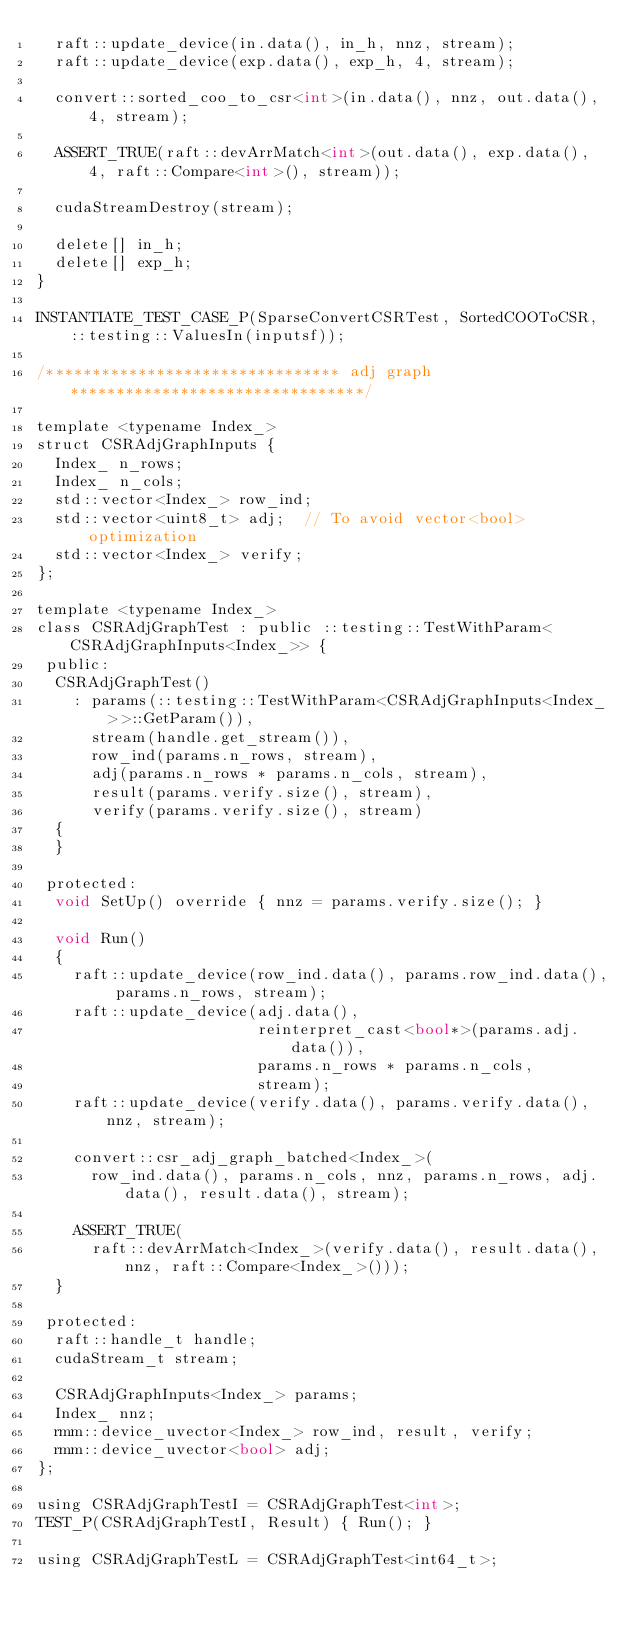<code> <loc_0><loc_0><loc_500><loc_500><_Cuda_>  raft::update_device(in.data(), in_h, nnz, stream);
  raft::update_device(exp.data(), exp_h, 4, stream);

  convert::sorted_coo_to_csr<int>(in.data(), nnz, out.data(), 4, stream);

  ASSERT_TRUE(raft::devArrMatch<int>(out.data(), exp.data(), 4, raft::Compare<int>(), stream));

  cudaStreamDestroy(stream);

  delete[] in_h;
  delete[] exp_h;
}

INSTANTIATE_TEST_CASE_P(SparseConvertCSRTest, SortedCOOToCSR, ::testing::ValuesIn(inputsf));

/******************************** adj graph ********************************/

template <typename Index_>
struct CSRAdjGraphInputs {
  Index_ n_rows;
  Index_ n_cols;
  std::vector<Index_> row_ind;
  std::vector<uint8_t> adj;  // To avoid vector<bool> optimization
  std::vector<Index_> verify;
};

template <typename Index_>
class CSRAdjGraphTest : public ::testing::TestWithParam<CSRAdjGraphInputs<Index_>> {
 public:
  CSRAdjGraphTest()
    : params(::testing::TestWithParam<CSRAdjGraphInputs<Index_>>::GetParam()),
      stream(handle.get_stream()),
      row_ind(params.n_rows, stream),
      adj(params.n_rows * params.n_cols, stream),
      result(params.verify.size(), stream),
      verify(params.verify.size(), stream)
  {
  }

 protected:
  void SetUp() override { nnz = params.verify.size(); }

  void Run()
  {
    raft::update_device(row_ind.data(), params.row_ind.data(), params.n_rows, stream);
    raft::update_device(adj.data(),
                        reinterpret_cast<bool*>(params.adj.data()),
                        params.n_rows * params.n_cols,
                        stream);
    raft::update_device(verify.data(), params.verify.data(), nnz, stream);

    convert::csr_adj_graph_batched<Index_>(
      row_ind.data(), params.n_cols, nnz, params.n_rows, adj.data(), result.data(), stream);

    ASSERT_TRUE(
      raft::devArrMatch<Index_>(verify.data(), result.data(), nnz, raft::Compare<Index_>()));
  }

 protected:
  raft::handle_t handle;
  cudaStream_t stream;

  CSRAdjGraphInputs<Index_> params;
  Index_ nnz;
  rmm::device_uvector<Index_> row_ind, result, verify;
  rmm::device_uvector<bool> adj;
};

using CSRAdjGraphTestI = CSRAdjGraphTest<int>;
TEST_P(CSRAdjGraphTestI, Result) { Run(); }

using CSRAdjGraphTestL = CSRAdjGraphTest<int64_t>;</code> 